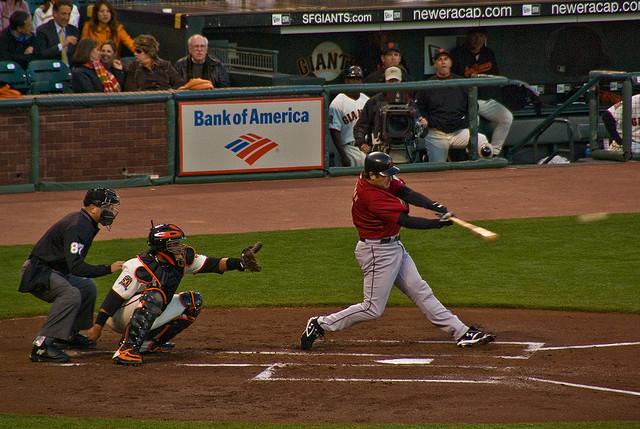What will the batter hit?
Be succinct. Ball. What color is the catcher's mitt?
Keep it brief. Brown. Is the batter right or left handed?
Quick response, please. Right. What bank is represented?
Short answer required. Bank of america. Which side is player 14 on?
Be succinct. Left. Will this batter hit a home run swinging that way?
Keep it brief. Yes. Will he hit the ball?
Quick response, please. Yes. What number is the umpire?
Quick response, please. 87. What color long sleeve shirt is the player on the left wearing?
Be succinct. Black. What team domain is in the background?
Quick response, please. Sf giants. Did the batter strike out?
Give a very brief answer. No. What logo is on the wall of the dugout?
Quick response, please. Bank of america. Which two teams are playing in this game?
Short answer required. Giants and neweracap. What company owns that sign?
Quick response, please. Bank of america. What is the main color people are wearing in the photo?
Give a very brief answer. Black. Are some spectators wearing hats?
Answer briefly. Yes. What is batter doing?
Concise answer only. Swinging. What color shirt is the runner wearing?
Answer briefly. Red. What ad is on the stands?
Keep it brief. Bank of america. Is this a professional sports game?
Answer briefly. Yes. What number does the umpire have on his sleeve?
Write a very short answer. 87. 